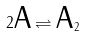Convert formula to latex. <formula><loc_0><loc_0><loc_500><loc_500>2 \text {A} \rightleftharpoons \text {A} _ { 2 }</formula> 